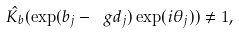<formula> <loc_0><loc_0><loc_500><loc_500>\hat { K _ { b } } ( \exp ( b _ { j } - \ g d _ { j } ) \exp ( i \theta _ { j } ) ) \neq 1 ,</formula> 